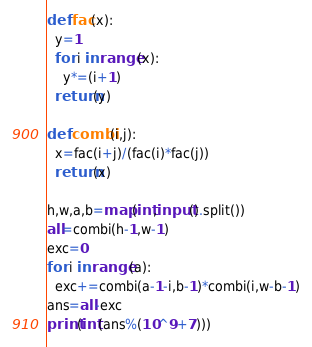<code> <loc_0><loc_0><loc_500><loc_500><_Python_>def fac(x):
  y=1
  for i in range(x):
    y*=(i+1)
  return(y)

def combi(i,j):
  x=fac(i+j)/(fac(i)*fac(j))
  return(x)

h,w,a,b=map(int,input().split())
all=combi(h-1,w-1)
exc=0
for i in range(a):
  exc+=combi(a-1-i,b-1)*combi(i,w-b-1)
ans=all-exc
print(int(ans%(10^9+7)))
</code> 